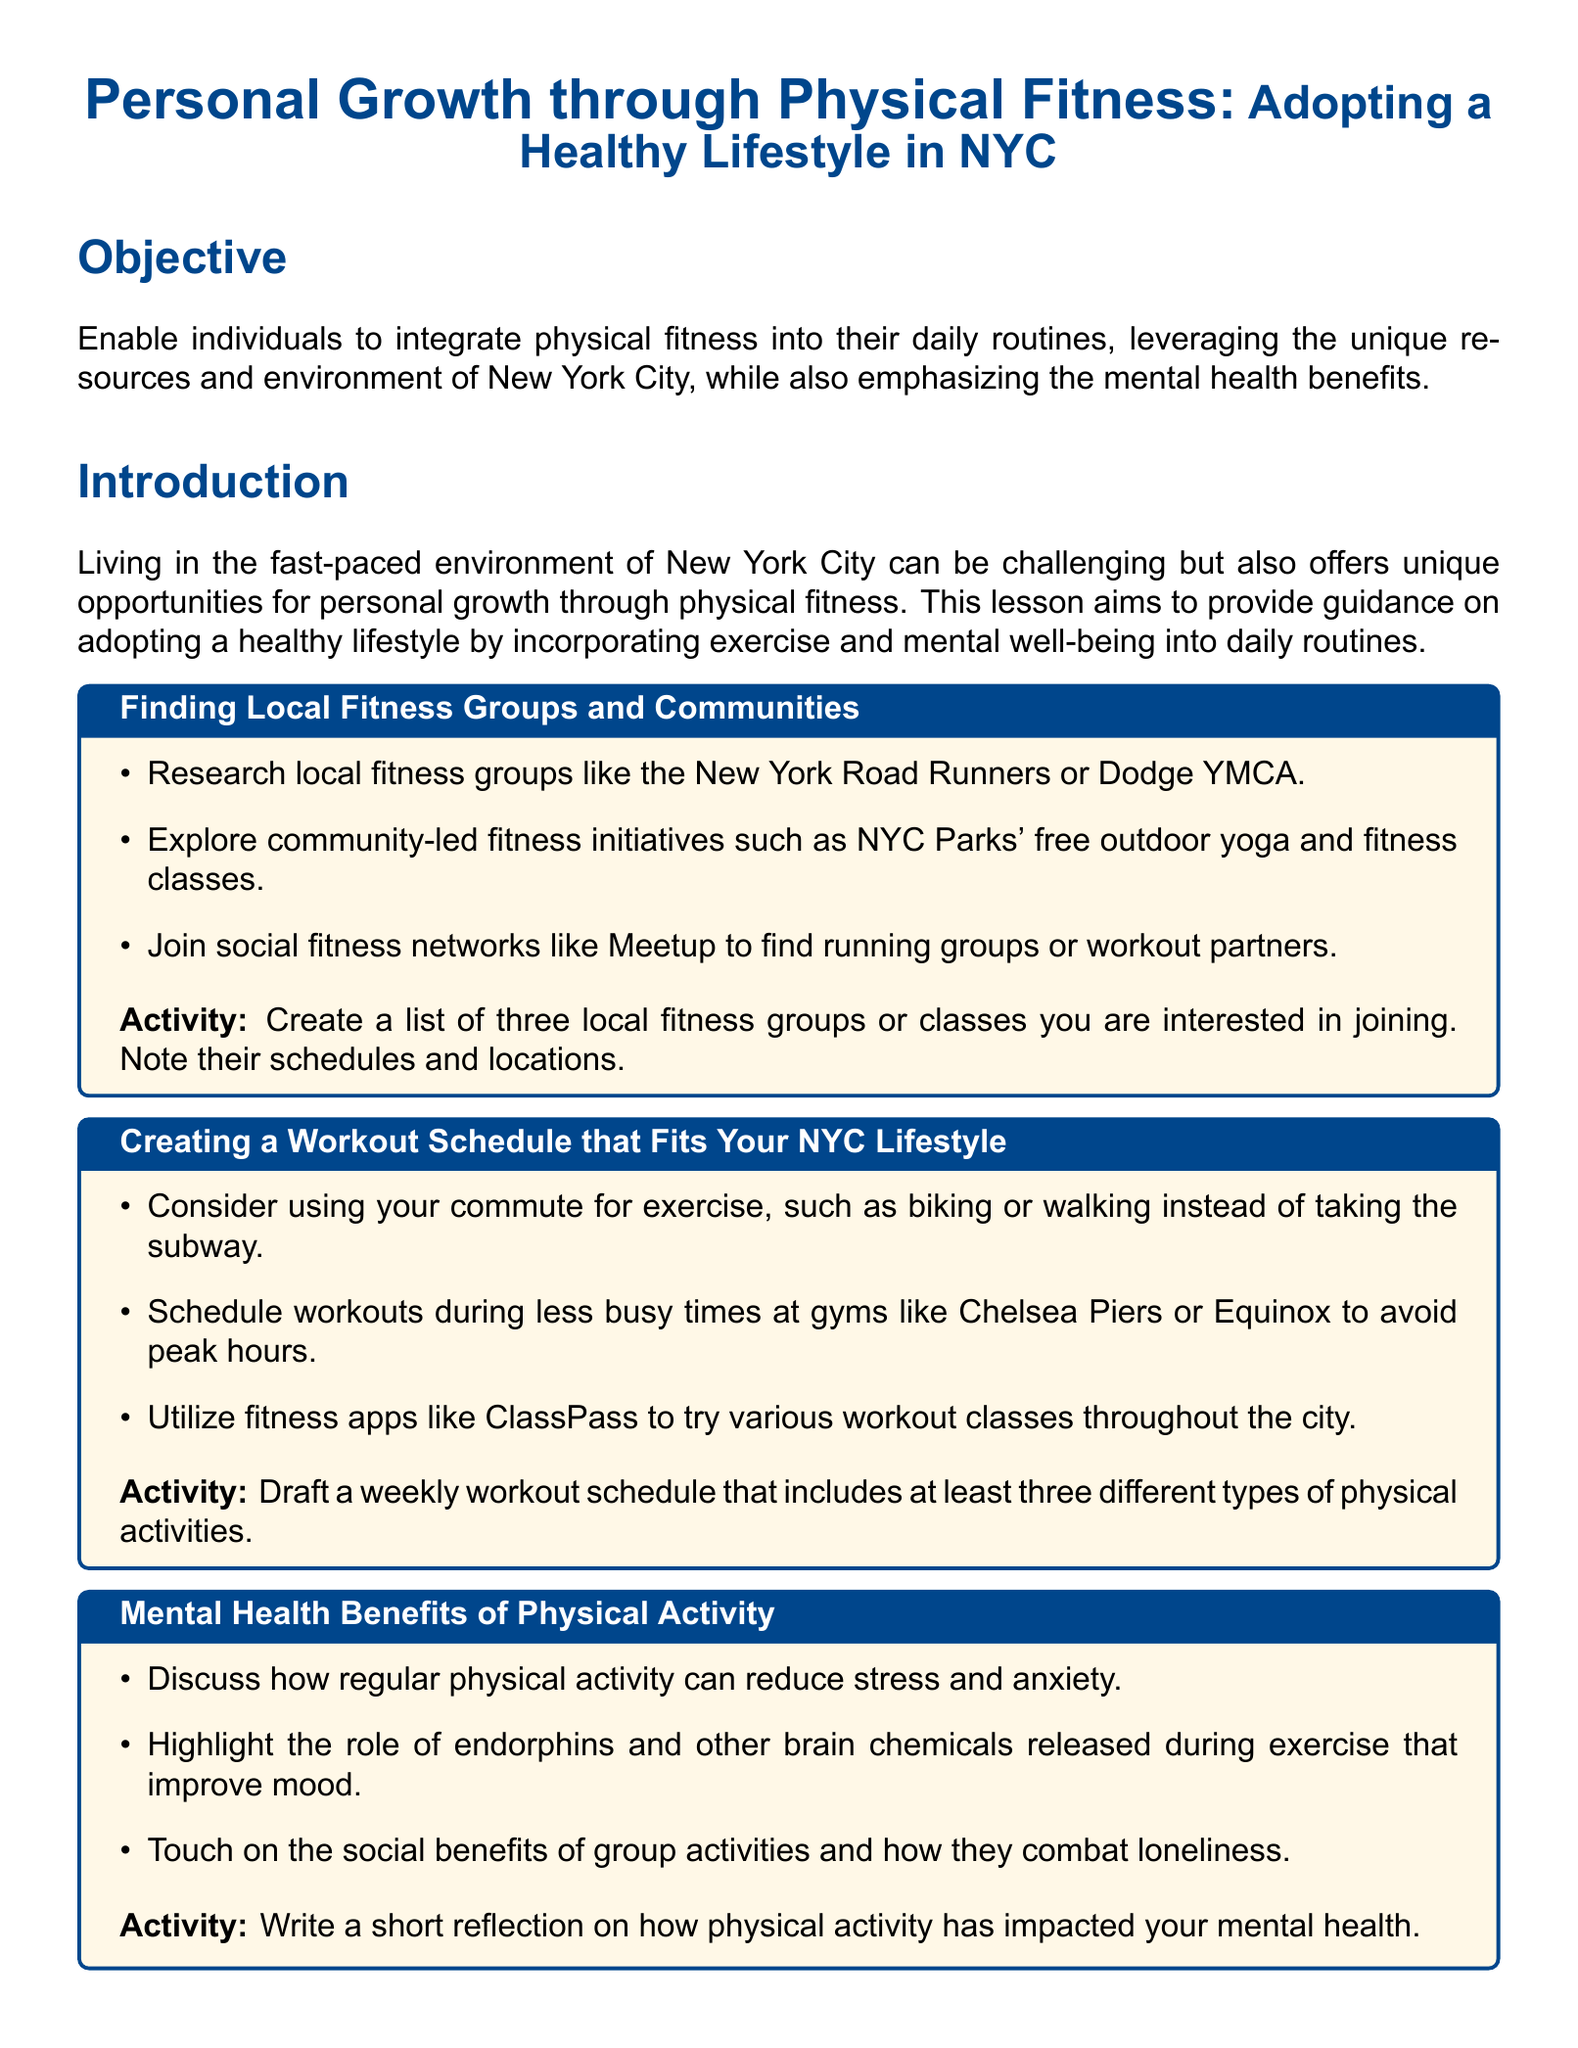What is the main objective of the lesson? The objective is to enable individuals to integrate physical fitness into their daily routines while emphasizing mental health benefits.
Answer: Enable individuals to integrate physical fitness into their daily routines, leveraging the unique resources and environment of New York City, while also emphasizing the mental health benefits Which local fitness group is mentioned in the document? The document lists fitness groups including the New York Road Runners and Dodge YMCA as examples.
Answer: New York Road Runners How many different types of physical activities should be included in the workout schedule? The document specifies that participants should draft a weekly workout schedule that includes at least three different types of physical activities.
Answer: Three What is one of the key parks listed for outdoor exercises? The document mentions parks such as Central Park as key locations for outdoor exercises.
Answer: Central Park What is one benefit of physical activity mentioned in the lesson? The lesson discusses benefits such as reducing stress and anxiety as a mental health benefit of physical activity.
Answer: Reduce stress and anxiety What materials are needed for this lesson? The materials listed include a notebook or digital device for planning and mapping, access to fitness apps, and internet access for research.
Answer: Notebook or digital device for planning and mapping What type of activity involves creating a personalized map? The document describes an activity that involves mapping local parks and gyms, highlighting favorite locations for fitness.
Answer: Mapping local parks and gyms How will participants be assessed? Participants will be assessed by presenting their personalized fitness maps and schedules to the group.
Answer: Present their personalized fitness maps and schedules to the group 